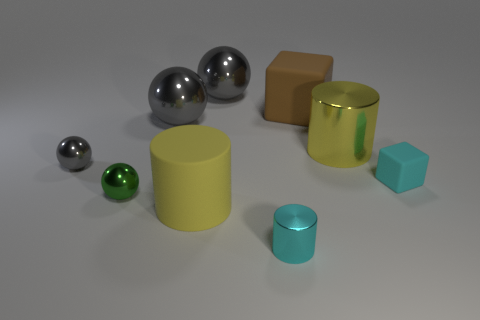There is a cyan thing that is the same size as the cyan cylinder; what is it made of?
Provide a short and direct response. Rubber. Are there any cyan cylinders of the same size as the yellow matte cylinder?
Provide a succinct answer. No. What is the color of the rubber object on the left side of the big brown rubber cube?
Offer a very short reply. Yellow. Is there a cyan thing that is to the left of the small cyan rubber object that is in front of the yellow shiny cylinder?
Your response must be concise. Yes. What number of other things are the same color as the tiny cylinder?
Your response must be concise. 1. There is a rubber block that is behind the small gray metal object; is it the same size as the yellow cylinder that is left of the yellow metal cylinder?
Provide a succinct answer. Yes. There is a block that is in front of the gray object that is on the left side of the green object; what is its size?
Your answer should be compact. Small. What material is the tiny object that is in front of the tiny block and on the right side of the green ball?
Make the answer very short. Metal. What color is the big cube?
Keep it short and to the point. Brown. Are there any other things that have the same material as the green thing?
Give a very brief answer. Yes. 